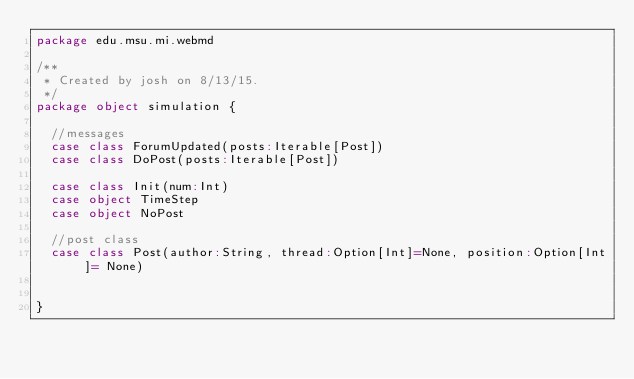<code> <loc_0><loc_0><loc_500><loc_500><_Scala_>package edu.msu.mi.webmd

/**
 * Created by josh on 8/13/15.
 */
package object simulation {

  //messages
  case class ForumUpdated(posts:Iterable[Post])
  case class DoPost(posts:Iterable[Post])

  case class Init(num:Int)
  case object TimeStep
  case object NoPost

  //post class
  case class Post(author:String, thread:Option[Int]=None, position:Option[Int]= None)


}
</code> 